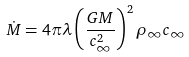<formula> <loc_0><loc_0><loc_500><loc_500>\dot { M } = 4 \pi \lambda \left ( \frac { G M } { c _ { \infty } ^ { 2 } } \right ) ^ { 2 } \rho _ { \infty } c _ { \infty }</formula> 